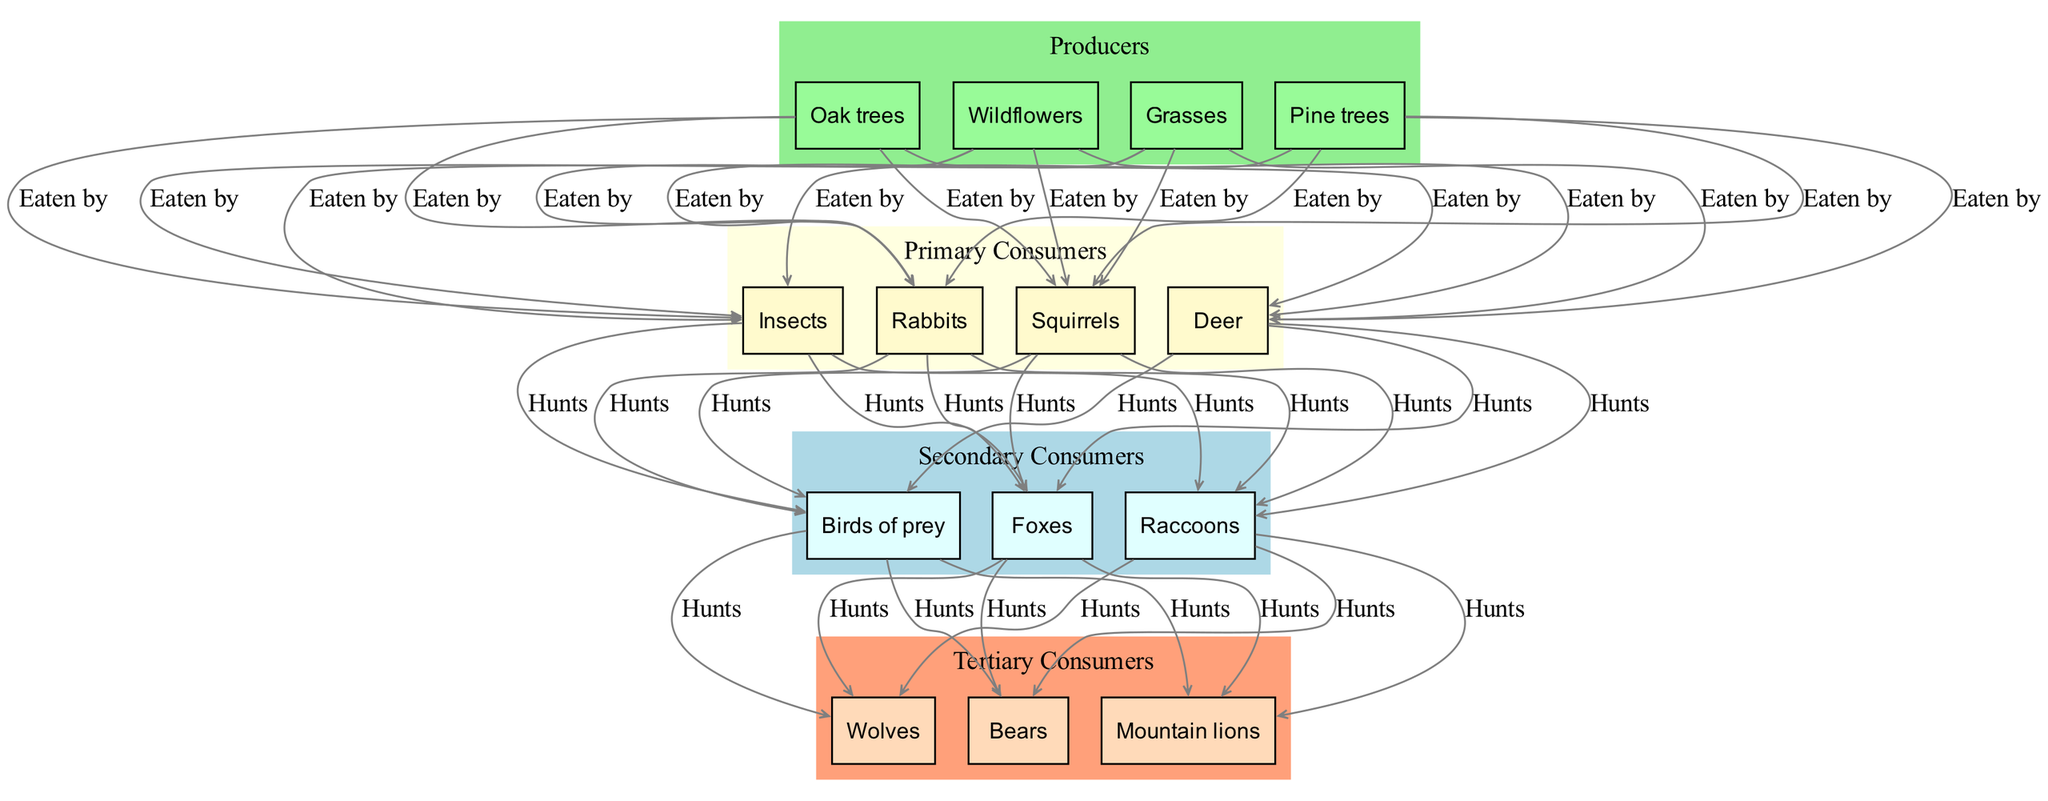What are the primary consumers in the food chain? The primary consumers listed in the diagram are Deer, Rabbits, Squirrels, and Insects. This information can be directly found in the section labeled "Primary Consumers."
Answer: Deer, Rabbits, Squirrels, Insects How many producers are there in total? The diagram shows four producers: Grasses, Pine trees, Oak trees, and Wildflowers. By counting the number of items listed in the "Producers" section, we find there are four.
Answer: 4 Which tertiary consumer is directly hunted by the secondary consumers? The tertiary consumers listed are Wolves, Bears, and Mountain lions. All of them are connected to the secondary consumers, Foxes, Raccoons, and Birds of prey, through the "Hunts" relationship. Therefore, all three tertiary consumers are hunted by secondary consumers.
Answer: Wolves, Bears, Mountain lions What type of relationship exists between primary consumers and producers? The relationship shown between primary consumers and producers is labeled "Eaten by." This can be visually confirmed by the arrows connecting the producers to the primary consumers in the diagram.
Answer: Eaten by Which primary consumer is hunted by secondary consumers? Looking at the "Hunts" relationship in the diagram, all primary consumers (Deer, Rabbits, Squirrels, Insects) are shown to be hunted by the secondary consumers (Foxes, Raccoons, Birds of prey). Therefore, all primary consumers have a connection through hunting relationships.
Answer: Deer, Rabbits, Squirrels, Insects How many edges are there from producers to primary consumers? Each producer is connected to each primary consumer with an "Eaten by" relationship. With four producers and four primary consumers, this results in a total of 16 edges (4 producers x 4 primary consumers). Thus, there are 16 edges connecting producers to primary consumers in the diagram.
Answer: 16 Which producers are connected to the primary consumers? The producers (Grasses, Pine trees, Oak trees, Wildflowers) are each connected to the primary consumers (Deer, Rabbits, Squirrels, Insects) with the relationship "Eaten by." Thus, all producers can be seen contributing to the diet of the primary consumers within the food chain.
Answer: Grasses, Pine trees, Oak trees, Wildflowers What is the highest consumer level in this food chain? The highest consumer level illustrated in the diagram is the tertiary consumers, which include Wolves, Bears, and Mountain lions. This is confirmed by noting that no other consumer levels exist above this group in the presented structure.
Answer: Tertiary consumers 